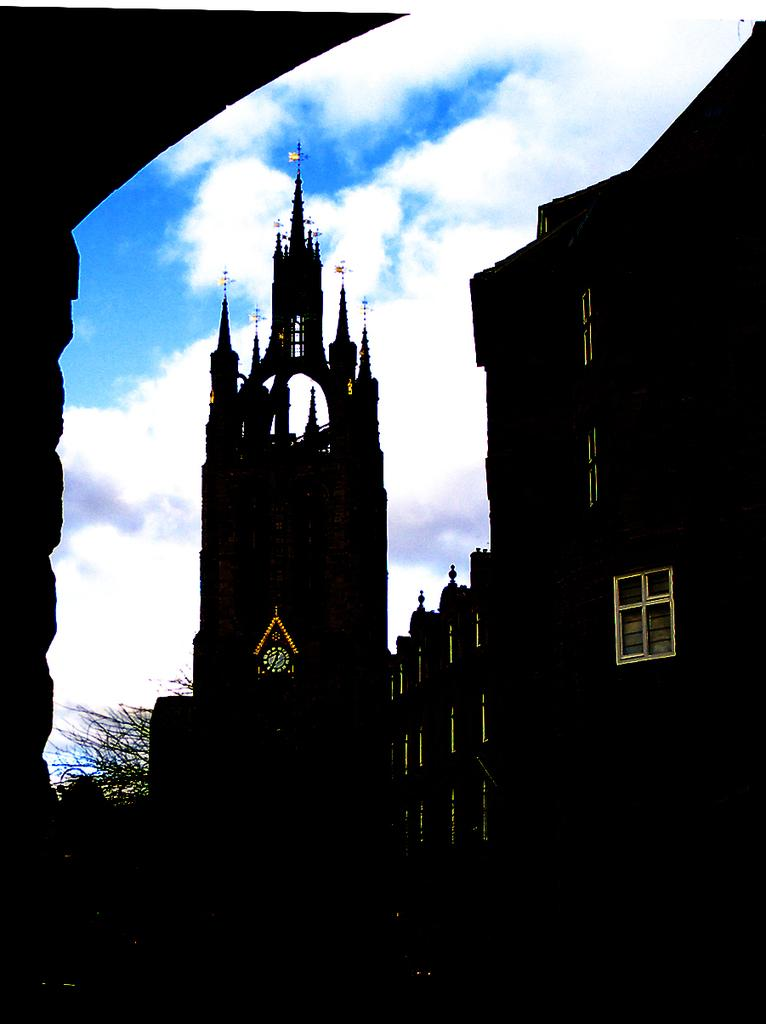What type of structures can be seen in the image? There are buildings in the image. Where is the clock located in the image? The clock is on a wall in the image. What type of vegetation is present in the image? There are trees in the image. What is visible at the top of the image? The sky is visible at the top of the image. What can be observed in the sky? There are clouds in the sky. What type of treatment is being administered to the buildings in the image? There is no treatment being administered to the buildings in the image; they are simply standing. What type of crime is being committed in the image? There is no crime being committed in the image; it is a scene of buildings, a clock, trees, and the sky. 